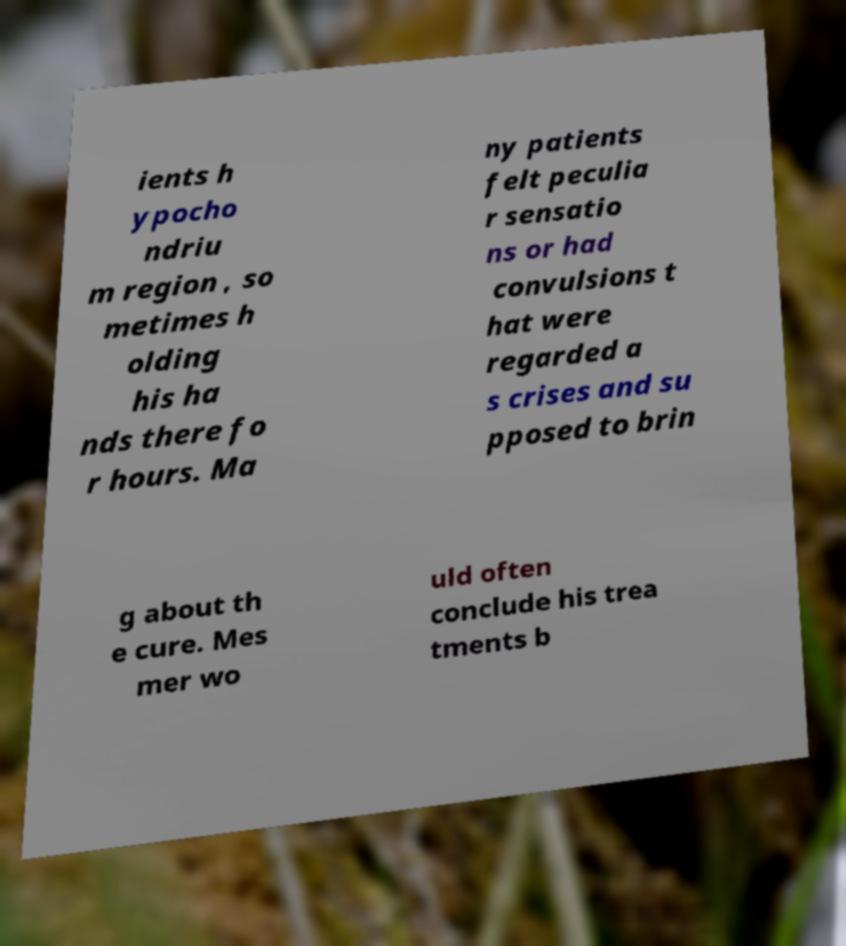There's text embedded in this image that I need extracted. Can you transcribe it verbatim? ients h ypocho ndriu m region , so metimes h olding his ha nds there fo r hours. Ma ny patients felt peculia r sensatio ns or had convulsions t hat were regarded a s crises and su pposed to brin g about th e cure. Mes mer wo uld often conclude his trea tments b 